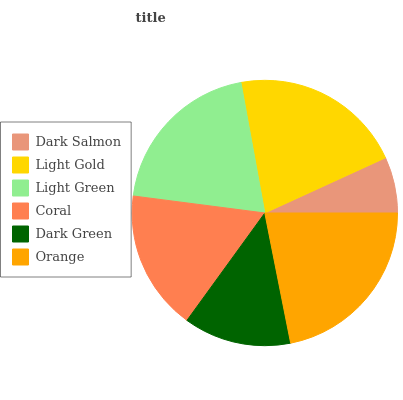Is Dark Salmon the minimum?
Answer yes or no. Yes. Is Orange the maximum?
Answer yes or no. Yes. Is Light Gold the minimum?
Answer yes or no. No. Is Light Gold the maximum?
Answer yes or no. No. Is Light Gold greater than Dark Salmon?
Answer yes or no. Yes. Is Dark Salmon less than Light Gold?
Answer yes or no. Yes. Is Dark Salmon greater than Light Gold?
Answer yes or no. No. Is Light Gold less than Dark Salmon?
Answer yes or no. No. Is Light Green the high median?
Answer yes or no. Yes. Is Coral the low median?
Answer yes or no. Yes. Is Dark Salmon the high median?
Answer yes or no. No. Is Dark Green the low median?
Answer yes or no. No. 